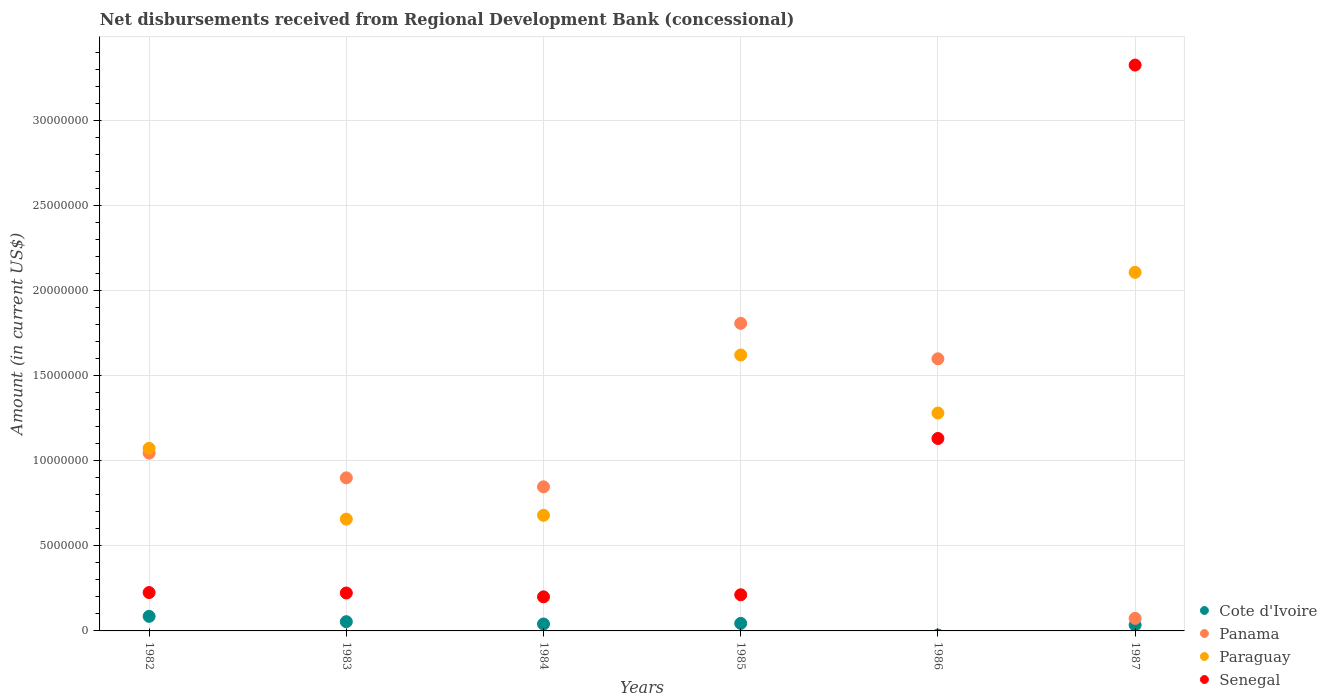How many different coloured dotlines are there?
Offer a very short reply. 4. What is the amount of disbursements received from Regional Development Bank in Cote d'Ivoire in 1987?
Provide a short and direct response. 3.47e+05. Across all years, what is the maximum amount of disbursements received from Regional Development Bank in Senegal?
Your answer should be compact. 3.33e+07. In which year was the amount of disbursements received from Regional Development Bank in Senegal maximum?
Your answer should be compact. 1987. What is the total amount of disbursements received from Regional Development Bank in Senegal in the graph?
Give a very brief answer. 5.32e+07. What is the difference between the amount of disbursements received from Regional Development Bank in Paraguay in 1984 and that in 1986?
Your response must be concise. -6.01e+06. What is the difference between the amount of disbursements received from Regional Development Bank in Cote d'Ivoire in 1985 and the amount of disbursements received from Regional Development Bank in Senegal in 1983?
Make the answer very short. -1.78e+06. What is the average amount of disbursements received from Regional Development Bank in Paraguay per year?
Make the answer very short. 1.24e+07. In the year 1983, what is the difference between the amount of disbursements received from Regional Development Bank in Paraguay and amount of disbursements received from Regional Development Bank in Cote d'Ivoire?
Offer a terse response. 6.03e+06. In how many years, is the amount of disbursements received from Regional Development Bank in Senegal greater than 26000000 US$?
Make the answer very short. 1. What is the ratio of the amount of disbursements received from Regional Development Bank in Senegal in 1982 to that in 1987?
Your answer should be compact. 0.07. Is the amount of disbursements received from Regional Development Bank in Panama in 1983 less than that in 1985?
Your answer should be compact. Yes. Is the difference between the amount of disbursements received from Regional Development Bank in Paraguay in 1983 and 1987 greater than the difference between the amount of disbursements received from Regional Development Bank in Cote d'Ivoire in 1983 and 1987?
Keep it short and to the point. No. What is the difference between the highest and the second highest amount of disbursements received from Regional Development Bank in Cote d'Ivoire?
Ensure brevity in your answer.  3.13e+05. What is the difference between the highest and the lowest amount of disbursements received from Regional Development Bank in Senegal?
Offer a very short reply. 3.13e+07. Is it the case that in every year, the sum of the amount of disbursements received from Regional Development Bank in Senegal and amount of disbursements received from Regional Development Bank in Paraguay  is greater than the sum of amount of disbursements received from Regional Development Bank in Cote d'Ivoire and amount of disbursements received from Regional Development Bank in Panama?
Your answer should be compact. Yes. How many dotlines are there?
Give a very brief answer. 4. Are the values on the major ticks of Y-axis written in scientific E-notation?
Offer a very short reply. No. Does the graph contain any zero values?
Keep it short and to the point. Yes. Does the graph contain grids?
Offer a very short reply. Yes. Where does the legend appear in the graph?
Offer a very short reply. Bottom right. How many legend labels are there?
Provide a short and direct response. 4. How are the legend labels stacked?
Provide a succinct answer. Vertical. What is the title of the graph?
Your answer should be compact. Net disbursements received from Regional Development Bank (concessional). Does "Jamaica" appear as one of the legend labels in the graph?
Offer a very short reply. No. What is the Amount (in current US$) of Cote d'Ivoire in 1982?
Keep it short and to the point. 8.56e+05. What is the Amount (in current US$) in Panama in 1982?
Your answer should be very brief. 1.04e+07. What is the Amount (in current US$) of Paraguay in 1982?
Provide a succinct answer. 1.07e+07. What is the Amount (in current US$) of Senegal in 1982?
Keep it short and to the point. 2.26e+06. What is the Amount (in current US$) in Cote d'Ivoire in 1983?
Ensure brevity in your answer.  5.43e+05. What is the Amount (in current US$) in Panama in 1983?
Your response must be concise. 9.00e+06. What is the Amount (in current US$) in Paraguay in 1983?
Your answer should be compact. 6.57e+06. What is the Amount (in current US$) of Senegal in 1983?
Offer a very short reply. 2.23e+06. What is the Amount (in current US$) of Cote d'Ivoire in 1984?
Ensure brevity in your answer.  4.07e+05. What is the Amount (in current US$) in Panama in 1984?
Give a very brief answer. 8.47e+06. What is the Amount (in current US$) of Paraguay in 1984?
Ensure brevity in your answer.  6.80e+06. What is the Amount (in current US$) in Senegal in 1984?
Offer a terse response. 2.00e+06. What is the Amount (in current US$) in Cote d'Ivoire in 1985?
Your answer should be compact. 4.43e+05. What is the Amount (in current US$) of Panama in 1985?
Provide a succinct answer. 1.81e+07. What is the Amount (in current US$) of Paraguay in 1985?
Ensure brevity in your answer.  1.62e+07. What is the Amount (in current US$) of Senegal in 1985?
Your answer should be very brief. 2.12e+06. What is the Amount (in current US$) in Panama in 1986?
Offer a terse response. 1.60e+07. What is the Amount (in current US$) of Paraguay in 1986?
Your answer should be compact. 1.28e+07. What is the Amount (in current US$) in Senegal in 1986?
Your response must be concise. 1.13e+07. What is the Amount (in current US$) in Cote d'Ivoire in 1987?
Ensure brevity in your answer.  3.47e+05. What is the Amount (in current US$) in Panama in 1987?
Offer a very short reply. 7.38e+05. What is the Amount (in current US$) of Paraguay in 1987?
Your answer should be very brief. 2.11e+07. What is the Amount (in current US$) in Senegal in 1987?
Keep it short and to the point. 3.33e+07. Across all years, what is the maximum Amount (in current US$) of Cote d'Ivoire?
Provide a succinct answer. 8.56e+05. Across all years, what is the maximum Amount (in current US$) in Panama?
Offer a very short reply. 1.81e+07. Across all years, what is the maximum Amount (in current US$) in Paraguay?
Your answer should be compact. 2.11e+07. Across all years, what is the maximum Amount (in current US$) in Senegal?
Give a very brief answer. 3.33e+07. Across all years, what is the minimum Amount (in current US$) of Panama?
Keep it short and to the point. 7.38e+05. Across all years, what is the minimum Amount (in current US$) in Paraguay?
Offer a very short reply. 6.57e+06. Across all years, what is the minimum Amount (in current US$) of Senegal?
Offer a very short reply. 2.00e+06. What is the total Amount (in current US$) in Cote d'Ivoire in the graph?
Make the answer very short. 2.60e+06. What is the total Amount (in current US$) of Panama in the graph?
Your response must be concise. 6.27e+07. What is the total Amount (in current US$) in Paraguay in the graph?
Provide a short and direct response. 7.42e+07. What is the total Amount (in current US$) in Senegal in the graph?
Your answer should be compact. 5.32e+07. What is the difference between the Amount (in current US$) in Cote d'Ivoire in 1982 and that in 1983?
Provide a short and direct response. 3.13e+05. What is the difference between the Amount (in current US$) of Panama in 1982 and that in 1983?
Make the answer very short. 1.45e+06. What is the difference between the Amount (in current US$) of Paraguay in 1982 and that in 1983?
Your answer should be compact. 4.16e+06. What is the difference between the Amount (in current US$) in Senegal in 1982 and that in 1983?
Your answer should be compact. 2.70e+04. What is the difference between the Amount (in current US$) in Cote d'Ivoire in 1982 and that in 1984?
Give a very brief answer. 4.49e+05. What is the difference between the Amount (in current US$) of Panama in 1982 and that in 1984?
Your answer should be very brief. 1.98e+06. What is the difference between the Amount (in current US$) in Paraguay in 1982 and that in 1984?
Your response must be concise. 3.93e+06. What is the difference between the Amount (in current US$) of Senegal in 1982 and that in 1984?
Offer a terse response. 2.52e+05. What is the difference between the Amount (in current US$) in Cote d'Ivoire in 1982 and that in 1985?
Give a very brief answer. 4.13e+05. What is the difference between the Amount (in current US$) of Panama in 1982 and that in 1985?
Your response must be concise. -7.63e+06. What is the difference between the Amount (in current US$) in Paraguay in 1982 and that in 1985?
Ensure brevity in your answer.  -5.49e+06. What is the difference between the Amount (in current US$) of Senegal in 1982 and that in 1985?
Give a very brief answer. 1.31e+05. What is the difference between the Amount (in current US$) of Panama in 1982 and that in 1986?
Give a very brief answer. -5.54e+06. What is the difference between the Amount (in current US$) in Paraguay in 1982 and that in 1986?
Ensure brevity in your answer.  -2.08e+06. What is the difference between the Amount (in current US$) in Senegal in 1982 and that in 1986?
Your answer should be compact. -9.06e+06. What is the difference between the Amount (in current US$) of Cote d'Ivoire in 1982 and that in 1987?
Offer a very short reply. 5.09e+05. What is the difference between the Amount (in current US$) in Panama in 1982 and that in 1987?
Make the answer very short. 9.71e+06. What is the difference between the Amount (in current US$) in Paraguay in 1982 and that in 1987?
Offer a terse response. -1.03e+07. What is the difference between the Amount (in current US$) in Senegal in 1982 and that in 1987?
Your answer should be very brief. -3.10e+07. What is the difference between the Amount (in current US$) of Cote d'Ivoire in 1983 and that in 1984?
Your answer should be very brief. 1.36e+05. What is the difference between the Amount (in current US$) of Panama in 1983 and that in 1984?
Ensure brevity in your answer.  5.27e+05. What is the difference between the Amount (in current US$) of Paraguay in 1983 and that in 1984?
Offer a very short reply. -2.26e+05. What is the difference between the Amount (in current US$) of Senegal in 1983 and that in 1984?
Ensure brevity in your answer.  2.25e+05. What is the difference between the Amount (in current US$) in Panama in 1983 and that in 1985?
Provide a short and direct response. -9.08e+06. What is the difference between the Amount (in current US$) in Paraguay in 1983 and that in 1985?
Your response must be concise. -9.64e+06. What is the difference between the Amount (in current US$) in Senegal in 1983 and that in 1985?
Provide a short and direct response. 1.04e+05. What is the difference between the Amount (in current US$) in Panama in 1983 and that in 1986?
Your answer should be very brief. -7.00e+06. What is the difference between the Amount (in current US$) in Paraguay in 1983 and that in 1986?
Give a very brief answer. -6.24e+06. What is the difference between the Amount (in current US$) in Senegal in 1983 and that in 1986?
Your answer should be very brief. -9.08e+06. What is the difference between the Amount (in current US$) of Cote d'Ivoire in 1983 and that in 1987?
Offer a terse response. 1.96e+05. What is the difference between the Amount (in current US$) of Panama in 1983 and that in 1987?
Provide a short and direct response. 8.26e+06. What is the difference between the Amount (in current US$) of Paraguay in 1983 and that in 1987?
Keep it short and to the point. -1.45e+07. What is the difference between the Amount (in current US$) of Senegal in 1983 and that in 1987?
Keep it short and to the point. -3.10e+07. What is the difference between the Amount (in current US$) in Cote d'Ivoire in 1984 and that in 1985?
Ensure brevity in your answer.  -3.60e+04. What is the difference between the Amount (in current US$) of Panama in 1984 and that in 1985?
Offer a terse response. -9.61e+06. What is the difference between the Amount (in current US$) in Paraguay in 1984 and that in 1985?
Offer a terse response. -9.42e+06. What is the difference between the Amount (in current US$) in Senegal in 1984 and that in 1985?
Your response must be concise. -1.21e+05. What is the difference between the Amount (in current US$) in Panama in 1984 and that in 1986?
Your answer should be compact. -7.52e+06. What is the difference between the Amount (in current US$) in Paraguay in 1984 and that in 1986?
Provide a short and direct response. -6.01e+06. What is the difference between the Amount (in current US$) in Senegal in 1984 and that in 1986?
Your response must be concise. -9.31e+06. What is the difference between the Amount (in current US$) in Panama in 1984 and that in 1987?
Your response must be concise. 7.73e+06. What is the difference between the Amount (in current US$) in Paraguay in 1984 and that in 1987?
Keep it short and to the point. -1.43e+07. What is the difference between the Amount (in current US$) of Senegal in 1984 and that in 1987?
Give a very brief answer. -3.13e+07. What is the difference between the Amount (in current US$) of Panama in 1985 and that in 1986?
Keep it short and to the point. 2.08e+06. What is the difference between the Amount (in current US$) in Paraguay in 1985 and that in 1986?
Ensure brevity in your answer.  3.41e+06. What is the difference between the Amount (in current US$) in Senegal in 1985 and that in 1986?
Give a very brief answer. -9.19e+06. What is the difference between the Amount (in current US$) in Cote d'Ivoire in 1985 and that in 1987?
Your answer should be very brief. 9.60e+04. What is the difference between the Amount (in current US$) of Panama in 1985 and that in 1987?
Offer a very short reply. 1.73e+07. What is the difference between the Amount (in current US$) in Paraguay in 1985 and that in 1987?
Provide a succinct answer. -4.86e+06. What is the difference between the Amount (in current US$) in Senegal in 1985 and that in 1987?
Keep it short and to the point. -3.11e+07. What is the difference between the Amount (in current US$) of Panama in 1986 and that in 1987?
Your answer should be compact. 1.53e+07. What is the difference between the Amount (in current US$) in Paraguay in 1986 and that in 1987?
Give a very brief answer. -8.27e+06. What is the difference between the Amount (in current US$) of Senegal in 1986 and that in 1987?
Your answer should be compact. -2.19e+07. What is the difference between the Amount (in current US$) in Cote d'Ivoire in 1982 and the Amount (in current US$) in Panama in 1983?
Ensure brevity in your answer.  -8.14e+06. What is the difference between the Amount (in current US$) of Cote d'Ivoire in 1982 and the Amount (in current US$) of Paraguay in 1983?
Offer a terse response. -5.72e+06. What is the difference between the Amount (in current US$) in Cote d'Ivoire in 1982 and the Amount (in current US$) in Senegal in 1983?
Your response must be concise. -1.37e+06. What is the difference between the Amount (in current US$) of Panama in 1982 and the Amount (in current US$) of Paraguay in 1983?
Keep it short and to the point. 3.88e+06. What is the difference between the Amount (in current US$) in Panama in 1982 and the Amount (in current US$) in Senegal in 1983?
Your answer should be very brief. 8.22e+06. What is the difference between the Amount (in current US$) of Paraguay in 1982 and the Amount (in current US$) of Senegal in 1983?
Keep it short and to the point. 8.50e+06. What is the difference between the Amount (in current US$) in Cote d'Ivoire in 1982 and the Amount (in current US$) in Panama in 1984?
Your answer should be very brief. -7.61e+06. What is the difference between the Amount (in current US$) in Cote d'Ivoire in 1982 and the Amount (in current US$) in Paraguay in 1984?
Offer a very short reply. -5.94e+06. What is the difference between the Amount (in current US$) in Cote d'Ivoire in 1982 and the Amount (in current US$) in Senegal in 1984?
Give a very brief answer. -1.15e+06. What is the difference between the Amount (in current US$) of Panama in 1982 and the Amount (in current US$) of Paraguay in 1984?
Your answer should be compact. 3.65e+06. What is the difference between the Amount (in current US$) of Panama in 1982 and the Amount (in current US$) of Senegal in 1984?
Provide a short and direct response. 8.45e+06. What is the difference between the Amount (in current US$) of Paraguay in 1982 and the Amount (in current US$) of Senegal in 1984?
Provide a succinct answer. 8.73e+06. What is the difference between the Amount (in current US$) of Cote d'Ivoire in 1982 and the Amount (in current US$) of Panama in 1985?
Provide a succinct answer. -1.72e+07. What is the difference between the Amount (in current US$) of Cote d'Ivoire in 1982 and the Amount (in current US$) of Paraguay in 1985?
Offer a very short reply. -1.54e+07. What is the difference between the Amount (in current US$) in Cote d'Ivoire in 1982 and the Amount (in current US$) in Senegal in 1985?
Your answer should be compact. -1.27e+06. What is the difference between the Amount (in current US$) of Panama in 1982 and the Amount (in current US$) of Paraguay in 1985?
Provide a short and direct response. -5.77e+06. What is the difference between the Amount (in current US$) of Panama in 1982 and the Amount (in current US$) of Senegal in 1985?
Keep it short and to the point. 8.32e+06. What is the difference between the Amount (in current US$) of Paraguay in 1982 and the Amount (in current US$) of Senegal in 1985?
Your answer should be compact. 8.60e+06. What is the difference between the Amount (in current US$) in Cote d'Ivoire in 1982 and the Amount (in current US$) in Panama in 1986?
Offer a terse response. -1.51e+07. What is the difference between the Amount (in current US$) in Cote d'Ivoire in 1982 and the Amount (in current US$) in Paraguay in 1986?
Your answer should be very brief. -1.20e+07. What is the difference between the Amount (in current US$) in Cote d'Ivoire in 1982 and the Amount (in current US$) in Senegal in 1986?
Your answer should be very brief. -1.05e+07. What is the difference between the Amount (in current US$) of Panama in 1982 and the Amount (in current US$) of Paraguay in 1986?
Give a very brief answer. -2.36e+06. What is the difference between the Amount (in current US$) in Panama in 1982 and the Amount (in current US$) in Senegal in 1986?
Your response must be concise. -8.61e+05. What is the difference between the Amount (in current US$) in Paraguay in 1982 and the Amount (in current US$) in Senegal in 1986?
Keep it short and to the point. -5.81e+05. What is the difference between the Amount (in current US$) in Cote d'Ivoire in 1982 and the Amount (in current US$) in Panama in 1987?
Offer a very short reply. 1.18e+05. What is the difference between the Amount (in current US$) in Cote d'Ivoire in 1982 and the Amount (in current US$) in Paraguay in 1987?
Offer a terse response. -2.02e+07. What is the difference between the Amount (in current US$) of Cote d'Ivoire in 1982 and the Amount (in current US$) of Senegal in 1987?
Your response must be concise. -3.24e+07. What is the difference between the Amount (in current US$) of Panama in 1982 and the Amount (in current US$) of Paraguay in 1987?
Provide a short and direct response. -1.06e+07. What is the difference between the Amount (in current US$) in Panama in 1982 and the Amount (in current US$) in Senegal in 1987?
Offer a terse response. -2.28e+07. What is the difference between the Amount (in current US$) of Paraguay in 1982 and the Amount (in current US$) of Senegal in 1987?
Keep it short and to the point. -2.25e+07. What is the difference between the Amount (in current US$) in Cote d'Ivoire in 1983 and the Amount (in current US$) in Panama in 1984?
Your answer should be very brief. -7.93e+06. What is the difference between the Amount (in current US$) in Cote d'Ivoire in 1983 and the Amount (in current US$) in Paraguay in 1984?
Offer a very short reply. -6.25e+06. What is the difference between the Amount (in current US$) of Cote d'Ivoire in 1983 and the Amount (in current US$) of Senegal in 1984?
Ensure brevity in your answer.  -1.46e+06. What is the difference between the Amount (in current US$) of Panama in 1983 and the Amount (in current US$) of Paraguay in 1984?
Make the answer very short. 2.20e+06. What is the difference between the Amount (in current US$) in Panama in 1983 and the Amount (in current US$) in Senegal in 1984?
Give a very brief answer. 6.99e+06. What is the difference between the Amount (in current US$) of Paraguay in 1983 and the Amount (in current US$) of Senegal in 1984?
Ensure brevity in your answer.  4.57e+06. What is the difference between the Amount (in current US$) in Cote d'Ivoire in 1983 and the Amount (in current US$) in Panama in 1985?
Ensure brevity in your answer.  -1.75e+07. What is the difference between the Amount (in current US$) in Cote d'Ivoire in 1983 and the Amount (in current US$) in Paraguay in 1985?
Keep it short and to the point. -1.57e+07. What is the difference between the Amount (in current US$) in Cote d'Ivoire in 1983 and the Amount (in current US$) in Senegal in 1985?
Your answer should be compact. -1.58e+06. What is the difference between the Amount (in current US$) of Panama in 1983 and the Amount (in current US$) of Paraguay in 1985?
Your answer should be very brief. -7.22e+06. What is the difference between the Amount (in current US$) in Panama in 1983 and the Amount (in current US$) in Senegal in 1985?
Provide a short and direct response. 6.87e+06. What is the difference between the Amount (in current US$) of Paraguay in 1983 and the Amount (in current US$) of Senegal in 1985?
Provide a succinct answer. 4.45e+06. What is the difference between the Amount (in current US$) of Cote d'Ivoire in 1983 and the Amount (in current US$) of Panama in 1986?
Give a very brief answer. -1.54e+07. What is the difference between the Amount (in current US$) in Cote d'Ivoire in 1983 and the Amount (in current US$) in Paraguay in 1986?
Provide a short and direct response. -1.23e+07. What is the difference between the Amount (in current US$) in Cote d'Ivoire in 1983 and the Amount (in current US$) in Senegal in 1986?
Provide a short and direct response. -1.08e+07. What is the difference between the Amount (in current US$) in Panama in 1983 and the Amount (in current US$) in Paraguay in 1986?
Your answer should be very brief. -3.81e+06. What is the difference between the Amount (in current US$) in Panama in 1983 and the Amount (in current US$) in Senegal in 1986?
Your response must be concise. -2.31e+06. What is the difference between the Amount (in current US$) of Paraguay in 1983 and the Amount (in current US$) of Senegal in 1986?
Ensure brevity in your answer.  -4.74e+06. What is the difference between the Amount (in current US$) of Cote d'Ivoire in 1983 and the Amount (in current US$) of Panama in 1987?
Make the answer very short. -1.95e+05. What is the difference between the Amount (in current US$) in Cote d'Ivoire in 1983 and the Amount (in current US$) in Paraguay in 1987?
Ensure brevity in your answer.  -2.05e+07. What is the difference between the Amount (in current US$) in Cote d'Ivoire in 1983 and the Amount (in current US$) in Senegal in 1987?
Your answer should be very brief. -3.27e+07. What is the difference between the Amount (in current US$) of Panama in 1983 and the Amount (in current US$) of Paraguay in 1987?
Your answer should be compact. -1.21e+07. What is the difference between the Amount (in current US$) in Panama in 1983 and the Amount (in current US$) in Senegal in 1987?
Ensure brevity in your answer.  -2.43e+07. What is the difference between the Amount (in current US$) of Paraguay in 1983 and the Amount (in current US$) of Senegal in 1987?
Provide a succinct answer. -2.67e+07. What is the difference between the Amount (in current US$) in Cote d'Ivoire in 1984 and the Amount (in current US$) in Panama in 1985?
Ensure brevity in your answer.  -1.77e+07. What is the difference between the Amount (in current US$) of Cote d'Ivoire in 1984 and the Amount (in current US$) of Paraguay in 1985?
Keep it short and to the point. -1.58e+07. What is the difference between the Amount (in current US$) in Cote d'Ivoire in 1984 and the Amount (in current US$) in Senegal in 1985?
Offer a very short reply. -1.72e+06. What is the difference between the Amount (in current US$) of Panama in 1984 and the Amount (in current US$) of Paraguay in 1985?
Ensure brevity in your answer.  -7.75e+06. What is the difference between the Amount (in current US$) of Panama in 1984 and the Amount (in current US$) of Senegal in 1985?
Give a very brief answer. 6.34e+06. What is the difference between the Amount (in current US$) in Paraguay in 1984 and the Amount (in current US$) in Senegal in 1985?
Your response must be concise. 4.67e+06. What is the difference between the Amount (in current US$) in Cote d'Ivoire in 1984 and the Amount (in current US$) in Panama in 1986?
Your answer should be very brief. -1.56e+07. What is the difference between the Amount (in current US$) in Cote d'Ivoire in 1984 and the Amount (in current US$) in Paraguay in 1986?
Give a very brief answer. -1.24e+07. What is the difference between the Amount (in current US$) of Cote d'Ivoire in 1984 and the Amount (in current US$) of Senegal in 1986?
Your answer should be very brief. -1.09e+07. What is the difference between the Amount (in current US$) in Panama in 1984 and the Amount (in current US$) in Paraguay in 1986?
Make the answer very short. -4.34e+06. What is the difference between the Amount (in current US$) of Panama in 1984 and the Amount (in current US$) of Senegal in 1986?
Provide a short and direct response. -2.84e+06. What is the difference between the Amount (in current US$) in Paraguay in 1984 and the Amount (in current US$) in Senegal in 1986?
Provide a short and direct response. -4.51e+06. What is the difference between the Amount (in current US$) of Cote d'Ivoire in 1984 and the Amount (in current US$) of Panama in 1987?
Give a very brief answer. -3.31e+05. What is the difference between the Amount (in current US$) of Cote d'Ivoire in 1984 and the Amount (in current US$) of Paraguay in 1987?
Your answer should be very brief. -2.07e+07. What is the difference between the Amount (in current US$) of Cote d'Ivoire in 1984 and the Amount (in current US$) of Senegal in 1987?
Give a very brief answer. -3.28e+07. What is the difference between the Amount (in current US$) of Panama in 1984 and the Amount (in current US$) of Paraguay in 1987?
Offer a terse response. -1.26e+07. What is the difference between the Amount (in current US$) in Panama in 1984 and the Amount (in current US$) in Senegal in 1987?
Ensure brevity in your answer.  -2.48e+07. What is the difference between the Amount (in current US$) in Paraguay in 1984 and the Amount (in current US$) in Senegal in 1987?
Make the answer very short. -2.65e+07. What is the difference between the Amount (in current US$) in Cote d'Ivoire in 1985 and the Amount (in current US$) in Panama in 1986?
Offer a very short reply. -1.56e+07. What is the difference between the Amount (in current US$) of Cote d'Ivoire in 1985 and the Amount (in current US$) of Paraguay in 1986?
Give a very brief answer. -1.24e+07. What is the difference between the Amount (in current US$) in Cote d'Ivoire in 1985 and the Amount (in current US$) in Senegal in 1986?
Provide a short and direct response. -1.09e+07. What is the difference between the Amount (in current US$) of Panama in 1985 and the Amount (in current US$) of Paraguay in 1986?
Your response must be concise. 5.27e+06. What is the difference between the Amount (in current US$) in Panama in 1985 and the Amount (in current US$) in Senegal in 1986?
Give a very brief answer. 6.76e+06. What is the difference between the Amount (in current US$) in Paraguay in 1985 and the Amount (in current US$) in Senegal in 1986?
Ensure brevity in your answer.  4.90e+06. What is the difference between the Amount (in current US$) of Cote d'Ivoire in 1985 and the Amount (in current US$) of Panama in 1987?
Your response must be concise. -2.95e+05. What is the difference between the Amount (in current US$) in Cote d'Ivoire in 1985 and the Amount (in current US$) in Paraguay in 1987?
Offer a very short reply. -2.06e+07. What is the difference between the Amount (in current US$) of Cote d'Ivoire in 1985 and the Amount (in current US$) of Senegal in 1987?
Your answer should be very brief. -3.28e+07. What is the difference between the Amount (in current US$) in Panama in 1985 and the Amount (in current US$) in Paraguay in 1987?
Give a very brief answer. -3.00e+06. What is the difference between the Amount (in current US$) of Panama in 1985 and the Amount (in current US$) of Senegal in 1987?
Your answer should be very brief. -1.52e+07. What is the difference between the Amount (in current US$) of Paraguay in 1985 and the Amount (in current US$) of Senegal in 1987?
Provide a succinct answer. -1.70e+07. What is the difference between the Amount (in current US$) of Panama in 1986 and the Amount (in current US$) of Paraguay in 1987?
Your answer should be compact. -5.08e+06. What is the difference between the Amount (in current US$) in Panama in 1986 and the Amount (in current US$) in Senegal in 1987?
Ensure brevity in your answer.  -1.73e+07. What is the difference between the Amount (in current US$) in Paraguay in 1986 and the Amount (in current US$) in Senegal in 1987?
Your answer should be compact. -2.04e+07. What is the average Amount (in current US$) in Cote d'Ivoire per year?
Your answer should be very brief. 4.33e+05. What is the average Amount (in current US$) of Panama per year?
Offer a terse response. 1.05e+07. What is the average Amount (in current US$) of Paraguay per year?
Your answer should be compact. 1.24e+07. What is the average Amount (in current US$) in Senegal per year?
Your response must be concise. 8.86e+06. In the year 1982, what is the difference between the Amount (in current US$) in Cote d'Ivoire and Amount (in current US$) in Panama?
Offer a terse response. -9.59e+06. In the year 1982, what is the difference between the Amount (in current US$) of Cote d'Ivoire and Amount (in current US$) of Paraguay?
Ensure brevity in your answer.  -9.87e+06. In the year 1982, what is the difference between the Amount (in current US$) of Cote d'Ivoire and Amount (in current US$) of Senegal?
Your response must be concise. -1.40e+06. In the year 1982, what is the difference between the Amount (in current US$) in Panama and Amount (in current US$) in Paraguay?
Provide a short and direct response. -2.80e+05. In the year 1982, what is the difference between the Amount (in current US$) of Panama and Amount (in current US$) of Senegal?
Offer a terse response. 8.19e+06. In the year 1982, what is the difference between the Amount (in current US$) in Paraguay and Amount (in current US$) in Senegal?
Your answer should be compact. 8.47e+06. In the year 1983, what is the difference between the Amount (in current US$) in Cote d'Ivoire and Amount (in current US$) in Panama?
Provide a short and direct response. -8.45e+06. In the year 1983, what is the difference between the Amount (in current US$) of Cote d'Ivoire and Amount (in current US$) of Paraguay?
Give a very brief answer. -6.03e+06. In the year 1983, what is the difference between the Amount (in current US$) in Cote d'Ivoire and Amount (in current US$) in Senegal?
Your answer should be compact. -1.68e+06. In the year 1983, what is the difference between the Amount (in current US$) of Panama and Amount (in current US$) of Paraguay?
Your answer should be very brief. 2.42e+06. In the year 1983, what is the difference between the Amount (in current US$) of Panama and Amount (in current US$) of Senegal?
Your answer should be very brief. 6.77e+06. In the year 1983, what is the difference between the Amount (in current US$) of Paraguay and Amount (in current US$) of Senegal?
Make the answer very short. 4.34e+06. In the year 1984, what is the difference between the Amount (in current US$) of Cote d'Ivoire and Amount (in current US$) of Panama?
Provide a succinct answer. -8.06e+06. In the year 1984, what is the difference between the Amount (in current US$) in Cote d'Ivoire and Amount (in current US$) in Paraguay?
Offer a very short reply. -6.39e+06. In the year 1984, what is the difference between the Amount (in current US$) of Cote d'Ivoire and Amount (in current US$) of Senegal?
Give a very brief answer. -1.60e+06. In the year 1984, what is the difference between the Amount (in current US$) in Panama and Amount (in current US$) in Paraguay?
Offer a terse response. 1.67e+06. In the year 1984, what is the difference between the Amount (in current US$) in Panama and Amount (in current US$) in Senegal?
Your answer should be compact. 6.47e+06. In the year 1984, what is the difference between the Amount (in current US$) of Paraguay and Amount (in current US$) of Senegal?
Make the answer very short. 4.79e+06. In the year 1985, what is the difference between the Amount (in current US$) in Cote d'Ivoire and Amount (in current US$) in Panama?
Give a very brief answer. -1.76e+07. In the year 1985, what is the difference between the Amount (in current US$) of Cote d'Ivoire and Amount (in current US$) of Paraguay?
Make the answer very short. -1.58e+07. In the year 1985, what is the difference between the Amount (in current US$) of Cote d'Ivoire and Amount (in current US$) of Senegal?
Provide a succinct answer. -1.68e+06. In the year 1985, what is the difference between the Amount (in current US$) of Panama and Amount (in current US$) of Paraguay?
Your response must be concise. 1.86e+06. In the year 1985, what is the difference between the Amount (in current US$) in Panama and Amount (in current US$) in Senegal?
Your answer should be compact. 1.60e+07. In the year 1985, what is the difference between the Amount (in current US$) of Paraguay and Amount (in current US$) of Senegal?
Offer a very short reply. 1.41e+07. In the year 1986, what is the difference between the Amount (in current US$) in Panama and Amount (in current US$) in Paraguay?
Provide a short and direct response. 3.19e+06. In the year 1986, what is the difference between the Amount (in current US$) in Panama and Amount (in current US$) in Senegal?
Offer a terse response. 4.68e+06. In the year 1986, what is the difference between the Amount (in current US$) of Paraguay and Amount (in current US$) of Senegal?
Provide a short and direct response. 1.50e+06. In the year 1987, what is the difference between the Amount (in current US$) of Cote d'Ivoire and Amount (in current US$) of Panama?
Keep it short and to the point. -3.91e+05. In the year 1987, what is the difference between the Amount (in current US$) of Cote d'Ivoire and Amount (in current US$) of Paraguay?
Your response must be concise. -2.07e+07. In the year 1987, what is the difference between the Amount (in current US$) of Cote d'Ivoire and Amount (in current US$) of Senegal?
Keep it short and to the point. -3.29e+07. In the year 1987, what is the difference between the Amount (in current US$) of Panama and Amount (in current US$) of Paraguay?
Offer a terse response. -2.03e+07. In the year 1987, what is the difference between the Amount (in current US$) of Panama and Amount (in current US$) of Senegal?
Ensure brevity in your answer.  -3.25e+07. In the year 1987, what is the difference between the Amount (in current US$) in Paraguay and Amount (in current US$) in Senegal?
Make the answer very short. -1.22e+07. What is the ratio of the Amount (in current US$) of Cote d'Ivoire in 1982 to that in 1983?
Offer a very short reply. 1.58. What is the ratio of the Amount (in current US$) in Panama in 1982 to that in 1983?
Offer a terse response. 1.16. What is the ratio of the Amount (in current US$) of Paraguay in 1982 to that in 1983?
Offer a very short reply. 1.63. What is the ratio of the Amount (in current US$) in Senegal in 1982 to that in 1983?
Give a very brief answer. 1.01. What is the ratio of the Amount (in current US$) in Cote d'Ivoire in 1982 to that in 1984?
Provide a short and direct response. 2.1. What is the ratio of the Amount (in current US$) of Panama in 1982 to that in 1984?
Your answer should be very brief. 1.23. What is the ratio of the Amount (in current US$) in Paraguay in 1982 to that in 1984?
Your answer should be very brief. 1.58. What is the ratio of the Amount (in current US$) of Senegal in 1982 to that in 1984?
Make the answer very short. 1.13. What is the ratio of the Amount (in current US$) of Cote d'Ivoire in 1982 to that in 1985?
Provide a succinct answer. 1.93. What is the ratio of the Amount (in current US$) of Panama in 1982 to that in 1985?
Provide a short and direct response. 0.58. What is the ratio of the Amount (in current US$) of Paraguay in 1982 to that in 1985?
Your response must be concise. 0.66. What is the ratio of the Amount (in current US$) of Senegal in 1982 to that in 1985?
Your answer should be compact. 1.06. What is the ratio of the Amount (in current US$) in Panama in 1982 to that in 1986?
Provide a short and direct response. 0.65. What is the ratio of the Amount (in current US$) in Paraguay in 1982 to that in 1986?
Provide a short and direct response. 0.84. What is the ratio of the Amount (in current US$) of Senegal in 1982 to that in 1986?
Provide a short and direct response. 0.2. What is the ratio of the Amount (in current US$) in Cote d'Ivoire in 1982 to that in 1987?
Keep it short and to the point. 2.47. What is the ratio of the Amount (in current US$) in Panama in 1982 to that in 1987?
Give a very brief answer. 14.16. What is the ratio of the Amount (in current US$) in Paraguay in 1982 to that in 1987?
Make the answer very short. 0.51. What is the ratio of the Amount (in current US$) in Senegal in 1982 to that in 1987?
Your answer should be very brief. 0.07. What is the ratio of the Amount (in current US$) of Cote d'Ivoire in 1983 to that in 1984?
Offer a very short reply. 1.33. What is the ratio of the Amount (in current US$) in Panama in 1983 to that in 1984?
Give a very brief answer. 1.06. What is the ratio of the Amount (in current US$) of Paraguay in 1983 to that in 1984?
Keep it short and to the point. 0.97. What is the ratio of the Amount (in current US$) in Senegal in 1983 to that in 1984?
Provide a short and direct response. 1.11. What is the ratio of the Amount (in current US$) in Cote d'Ivoire in 1983 to that in 1985?
Give a very brief answer. 1.23. What is the ratio of the Amount (in current US$) of Panama in 1983 to that in 1985?
Provide a succinct answer. 0.5. What is the ratio of the Amount (in current US$) of Paraguay in 1983 to that in 1985?
Your response must be concise. 0.41. What is the ratio of the Amount (in current US$) of Senegal in 1983 to that in 1985?
Provide a succinct answer. 1.05. What is the ratio of the Amount (in current US$) of Panama in 1983 to that in 1986?
Your answer should be very brief. 0.56. What is the ratio of the Amount (in current US$) in Paraguay in 1983 to that in 1986?
Ensure brevity in your answer.  0.51. What is the ratio of the Amount (in current US$) of Senegal in 1983 to that in 1986?
Make the answer very short. 0.2. What is the ratio of the Amount (in current US$) in Cote d'Ivoire in 1983 to that in 1987?
Make the answer very short. 1.56. What is the ratio of the Amount (in current US$) of Panama in 1983 to that in 1987?
Make the answer very short. 12.19. What is the ratio of the Amount (in current US$) in Paraguay in 1983 to that in 1987?
Your answer should be compact. 0.31. What is the ratio of the Amount (in current US$) in Senegal in 1983 to that in 1987?
Offer a terse response. 0.07. What is the ratio of the Amount (in current US$) of Cote d'Ivoire in 1984 to that in 1985?
Offer a terse response. 0.92. What is the ratio of the Amount (in current US$) in Panama in 1984 to that in 1985?
Your answer should be very brief. 0.47. What is the ratio of the Amount (in current US$) of Paraguay in 1984 to that in 1985?
Ensure brevity in your answer.  0.42. What is the ratio of the Amount (in current US$) in Senegal in 1984 to that in 1985?
Your answer should be very brief. 0.94. What is the ratio of the Amount (in current US$) in Panama in 1984 to that in 1986?
Provide a short and direct response. 0.53. What is the ratio of the Amount (in current US$) in Paraguay in 1984 to that in 1986?
Ensure brevity in your answer.  0.53. What is the ratio of the Amount (in current US$) of Senegal in 1984 to that in 1986?
Keep it short and to the point. 0.18. What is the ratio of the Amount (in current US$) in Cote d'Ivoire in 1984 to that in 1987?
Provide a succinct answer. 1.17. What is the ratio of the Amount (in current US$) of Panama in 1984 to that in 1987?
Your response must be concise. 11.48. What is the ratio of the Amount (in current US$) of Paraguay in 1984 to that in 1987?
Keep it short and to the point. 0.32. What is the ratio of the Amount (in current US$) in Senegal in 1984 to that in 1987?
Provide a short and direct response. 0.06. What is the ratio of the Amount (in current US$) in Panama in 1985 to that in 1986?
Your response must be concise. 1.13. What is the ratio of the Amount (in current US$) of Paraguay in 1985 to that in 1986?
Ensure brevity in your answer.  1.27. What is the ratio of the Amount (in current US$) of Senegal in 1985 to that in 1986?
Keep it short and to the point. 0.19. What is the ratio of the Amount (in current US$) in Cote d'Ivoire in 1985 to that in 1987?
Offer a terse response. 1.28. What is the ratio of the Amount (in current US$) in Panama in 1985 to that in 1987?
Make the answer very short. 24.49. What is the ratio of the Amount (in current US$) of Paraguay in 1985 to that in 1987?
Provide a short and direct response. 0.77. What is the ratio of the Amount (in current US$) of Senegal in 1985 to that in 1987?
Give a very brief answer. 0.06. What is the ratio of the Amount (in current US$) of Panama in 1986 to that in 1987?
Your answer should be compact. 21.67. What is the ratio of the Amount (in current US$) in Paraguay in 1986 to that in 1987?
Your answer should be very brief. 0.61. What is the ratio of the Amount (in current US$) in Senegal in 1986 to that in 1987?
Offer a very short reply. 0.34. What is the difference between the highest and the second highest Amount (in current US$) in Cote d'Ivoire?
Keep it short and to the point. 3.13e+05. What is the difference between the highest and the second highest Amount (in current US$) in Panama?
Make the answer very short. 2.08e+06. What is the difference between the highest and the second highest Amount (in current US$) in Paraguay?
Your answer should be compact. 4.86e+06. What is the difference between the highest and the second highest Amount (in current US$) of Senegal?
Offer a terse response. 2.19e+07. What is the difference between the highest and the lowest Amount (in current US$) in Cote d'Ivoire?
Ensure brevity in your answer.  8.56e+05. What is the difference between the highest and the lowest Amount (in current US$) of Panama?
Offer a terse response. 1.73e+07. What is the difference between the highest and the lowest Amount (in current US$) in Paraguay?
Offer a very short reply. 1.45e+07. What is the difference between the highest and the lowest Amount (in current US$) of Senegal?
Give a very brief answer. 3.13e+07. 